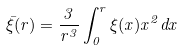Convert formula to latex. <formula><loc_0><loc_0><loc_500><loc_500>\bar { \xi } ( r ) = \frac { 3 } { r ^ { 3 } } \int _ { 0 } ^ { r } \xi ( x ) x ^ { 2 } d x</formula> 